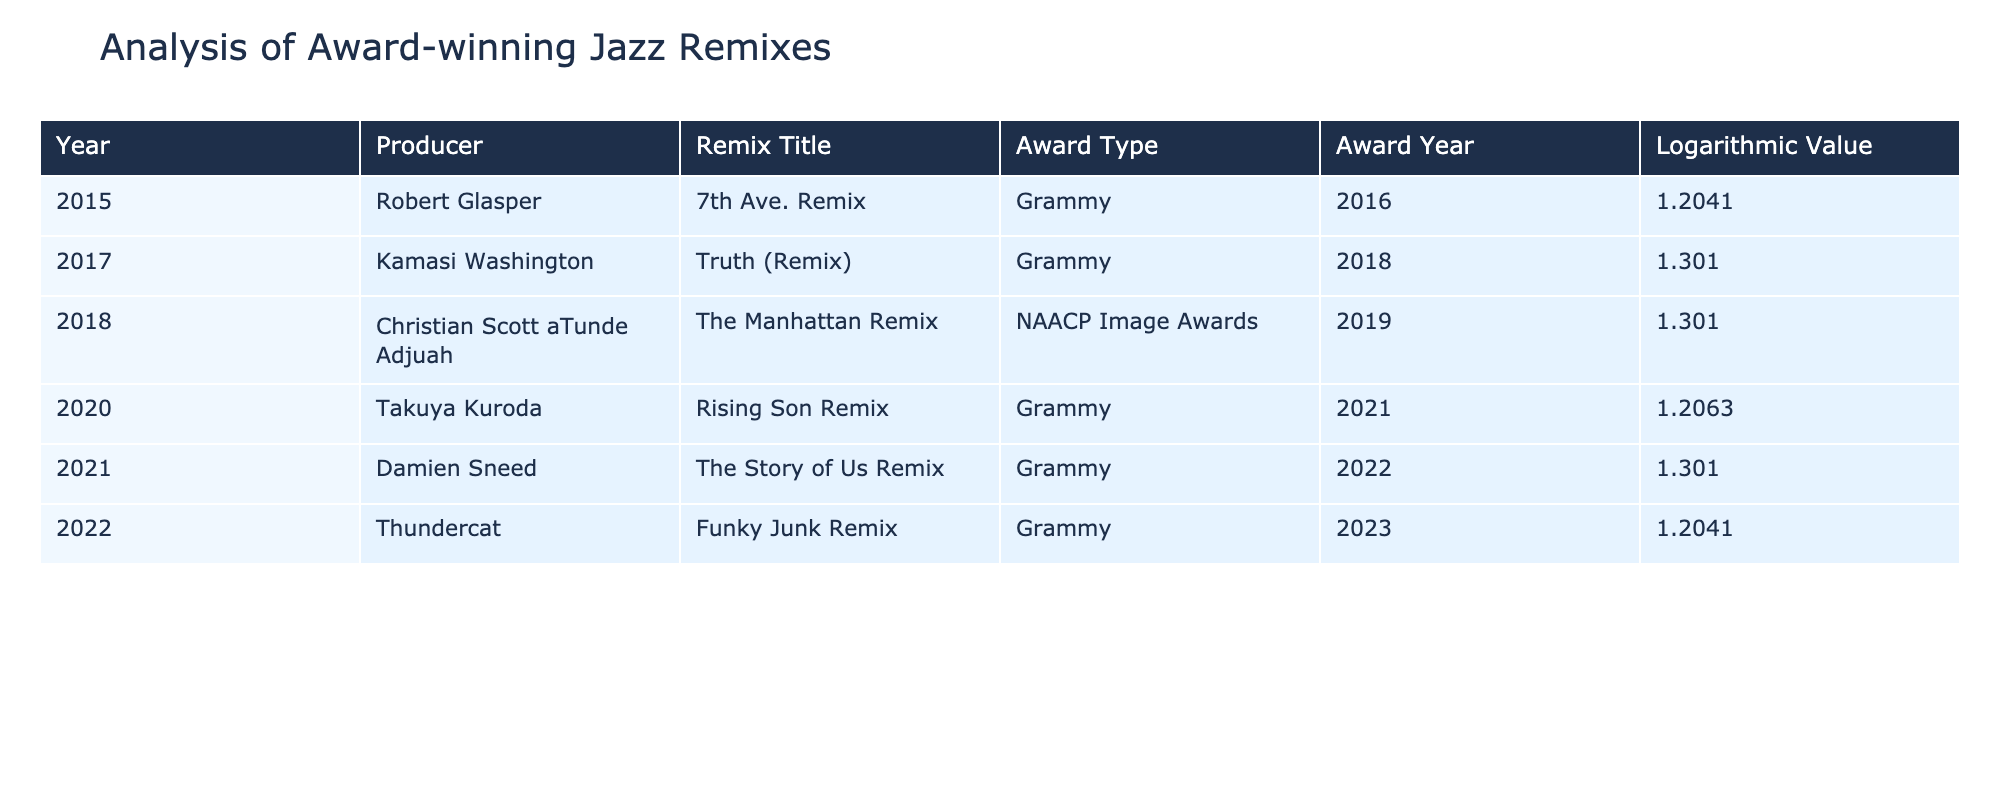What is the Grammy-winning remix title produced by Robert Glasper? According to the table, the title for the Grammy-winning remix by Robert Glasper in 2016 is "7th Ave. Remix."
Answer: 7th Ave. Remix Which producer created a remix that won a Grammy in 2022? From the table, Damien Sneed is listed as the producer for "The Story of Us Remix," which won a Grammy in 2022.
Answer: Damien Sneed What is the logarithmic value of the remix titled "Truth (Remix)"? The table lists "Truth (Remix)" by Kamasi Washington, with a logarithmic value of 1.3010.
Answer: 1.3010 Which year saw the most Grammy-winning remixes according to the table, and how many were there? The table shows that there are four Grammy-winning remixes (2016, 2018, 2021, and 2022), with 2021 and 2022 as years with Grammy winners, but since only 2021 features one entry, it cannot be the year with the most. Thus, the answer is multiple years with one entry.
Answer: 2016, 2018, 2021, 2022 - four entries total Is the remix "The Manhattan Remix" awarded by NAACP Image Awards? The table indicates that "The Manhattan Remix" by Christian Scott aTunde Adjuah won an NAACP Image Award, confirming the affirmation.
Answer: Yes What is the average logarithmic value of all remixes listed in the table? The logarithmic values listed are 1.2041, 1.3010, 1.3010, 1.2063, 1.3010, and 1.2041, which sum up to 7.5175. Dividing by the total number of remixes (6) gives an average of approximately 1.2529.
Answer: 1.2529 What is the total number of awards received by Takuya Kuroda? Takuya Kuroda is listed with one entry for the Grammy-winning remix in 2021, thus he received one award.
Answer: 1 Did any of the remixes receive an award type other than Grammy or NAACP Image Awards? According to the table, all entries are either Grammy or NAACP Image Awards, confirming there were no other award types present.
Answer: No What is the highest logarithmic value among the remixes listed in the table? The values of the logarithmic values are 1.3010 (which appears three times). Therefore, the highest logarithmic value is 1.3010.
Answer: 1.3010 